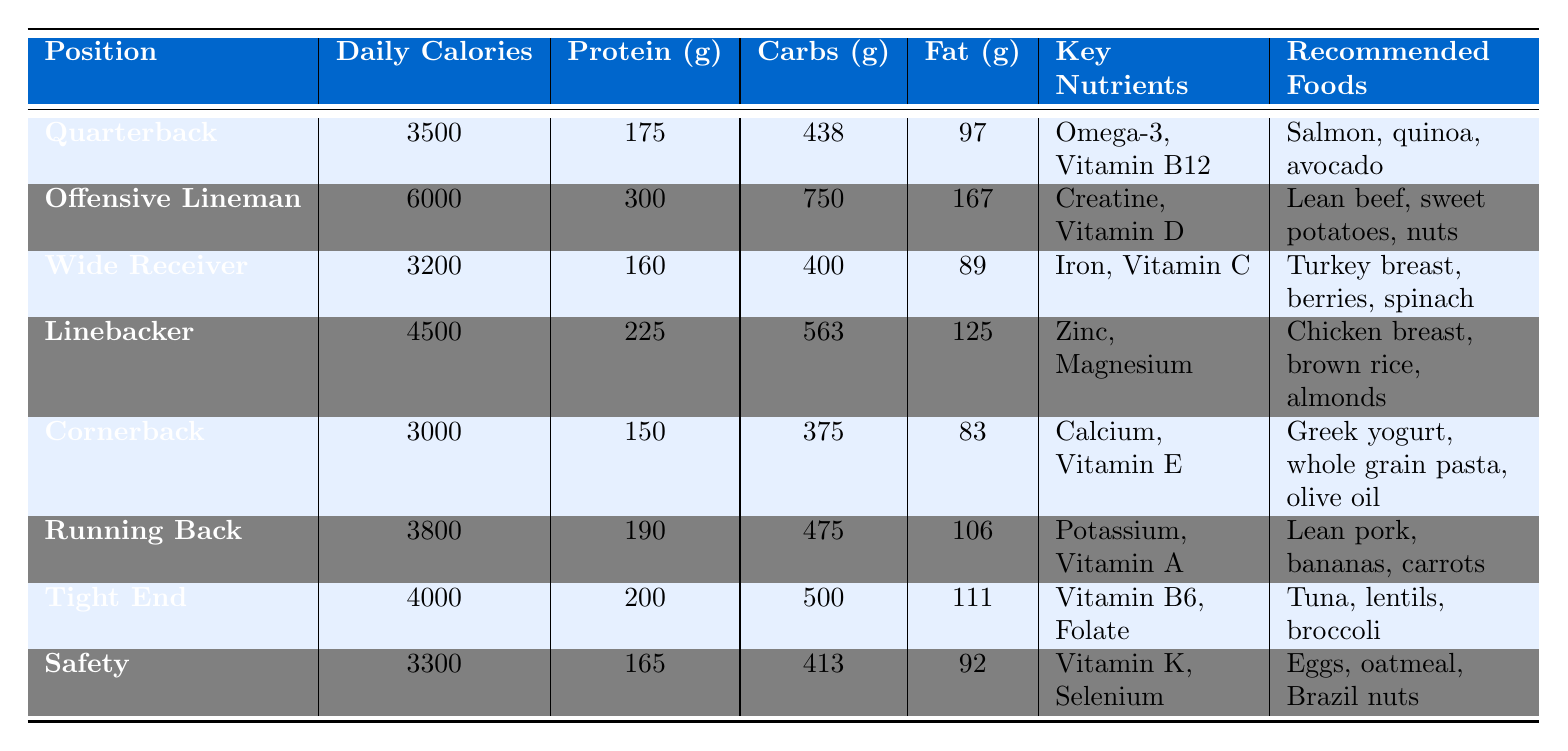What is the daily calorie requirement for a Linebacker? The table shows that the daily calorie requirement for a Linebacker is listed as 4500.
Answer: 4500 Which position requires the highest amount of protein? By examining the protein values in the table, the Offensive Lineman has the highest protein requirement at 300 grams.
Answer: Offensive Lineman How much more carbohydrate is needed by an Offensive Lineman compared to a Cornerback? The Offensive Lineman requires 750 grams of carbohydrates while the Cornerback requires 375 grams. The difference is calculated as 750 - 375 = 375 grams.
Answer: 375 grams Is the daily calorie requirement for a Quarterback greater than that for a Safety? The daily calorie requirement for a Quarterback is 3500 and for a Safety is 3300. Since 3500 is greater than 3300, the statement is true.
Answer: Yes What is the total daily calorie requirement for a Running Back and a Tight End combined? The daily calorie requirement for a Running Back is 3800 and for a Tight End is 4000. Adding these together, 3800 + 4000 = 7800 calories.
Answer: 7800 calories What percentage of the daily calories for a Wide Receiver comes from protein? The Wide Receiver requires 3200 calories with 160 grams of protein. First, convert protein to calories: 160 grams of protein × 4 = 640 calories. Then, calculate the percentage: (640 / 3200) × 100 = 20%.
Answer: 20% If a player wants to follow the recommended foods for a Tight End, what are the three suggested foods? The table lists Tuna, lentils, and broccoli as the recommended foods for a Tight End.
Answer: Tuna, lentils, broccoli Which position has the lowest daily calorie requirement? The table shows that the Cornerback has the lowest daily calorie requirement at 3000 calories.
Answer: Cornerback If a player needs to increase their fat intake, which position's requirement should they aim to meet? The Offensive Lineman requires the highest amount of fat at 167 grams, according to the table. Therefore, a player should aim for this amount.
Answer: Offensive Lineman How many grams of protein should a Safety consume compared to a Running Back? The Safety requires 165 grams of protein while the Running Back requires 190 grams. The difference is 190 - 165 = 25 grams. Therefore, a Safety should consume 25 grams less than a Running Back.
Answer: 25 grams less 